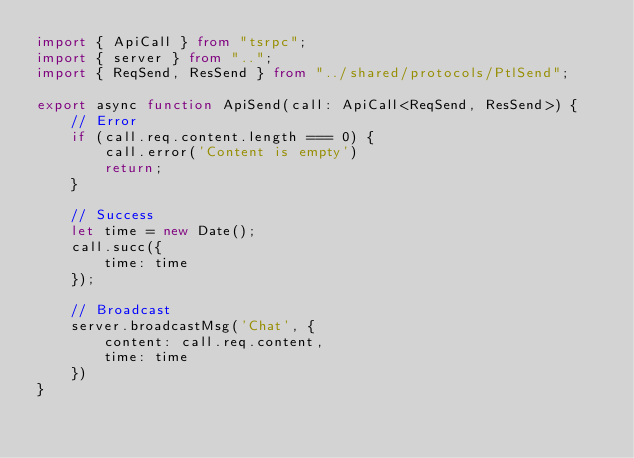<code> <loc_0><loc_0><loc_500><loc_500><_TypeScript_>import { ApiCall } from "tsrpc";
import { server } from "..";
import { ReqSend, ResSend } from "../shared/protocols/PtlSend";

export async function ApiSend(call: ApiCall<ReqSend, ResSend>) {
    // Error
    if (call.req.content.length === 0) {
        call.error('Content is empty')
        return;
    }

    // Success
    let time = new Date();
    call.succ({
        time: time
    });

    // Broadcast
    server.broadcastMsg('Chat', {
        content: call.req.content,
        time: time
    })
}</code> 